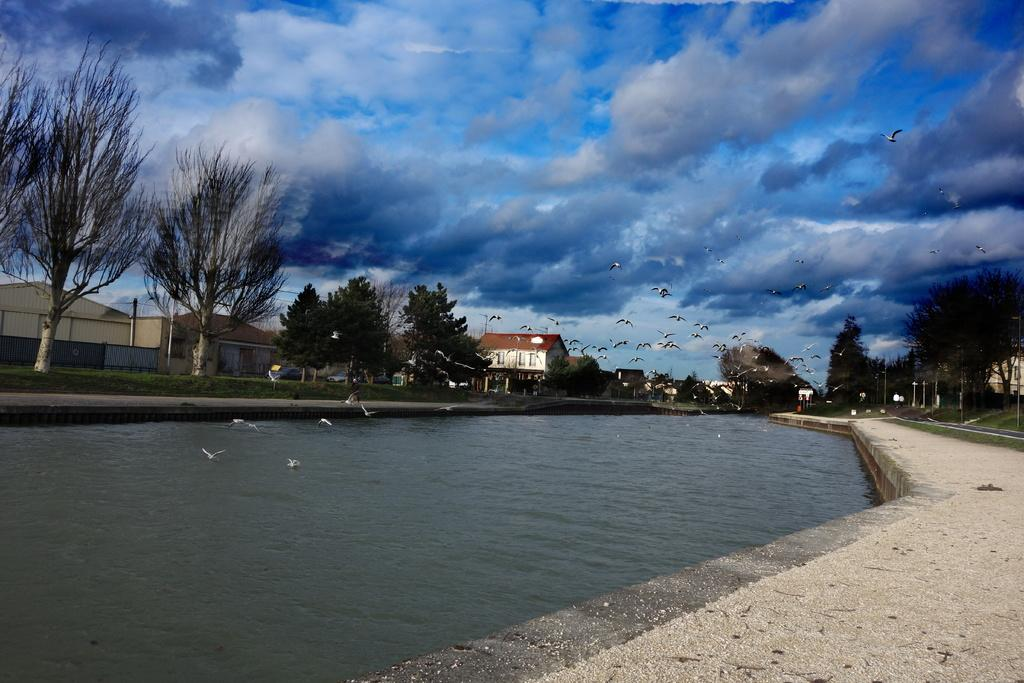What type of structures can be seen in the image? There are buildings in the image. What other natural elements are present in the image? There are trees and water visible in the image. What are the poles used for in the image? The purpose of the poles is not specified, but they are present in the image. What is happening in the sky in the image? The sky is blue and white in color, and birds are flying in the image. What route do the birds take to push the buildings in the image? There is no indication in the image that the birds are pushing the buildings, nor is there a specified route for them to do so. 